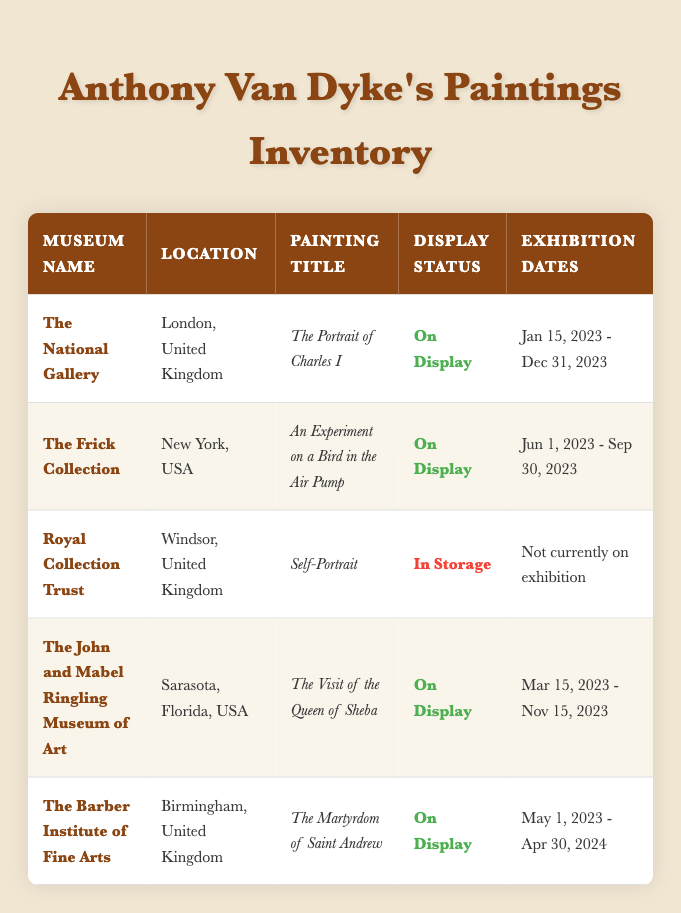What is the location of The Frick Collection? The table specifies the location of The Frick Collection under the "Location" column. It states that the museum is located in New York, USA.
Answer: New York, USA Which painting by Van Dyke is currently In Storage? By scanning the "Current Display Status" column, it is evident that the painting with the status "In Storage" is "Self-Portrait" held by the Royal Collection Trust.
Answer: Self-Portrait How many paintings are currently On Display? In the "Current Display Status" column, there are four paintings listed as "On Display." I counted each row where this status is present: The Portrait of Charles I, An Experiment on a Bird in the Air Pump, The Visit of the Queen of Sheba, and The Martyrdom of Saint Andrew.
Answer: 4 Is "The Martyrdom of Saint Andrew" currently on display? The table shows that the current display status of "The Martyrdom of Saint Andrew" is noted as "On Display." Therefore, it is true that it is currently being exhibited.
Answer: Yes Which museum has the longest ongoing exhibition for Van Dyke's paintings? I need to compare the exhibition dates of all paintings currently on display. The Barber Institute of Fine Arts has the exhibition lasting from May 1, 2023, to April 30, 2024, which is 12 months. The other exhibitions are shorter: The National Gallery till December 31, 2023, The Ringling Museum until November 15, 2023, and The Frick Collection until September 30, 2023. Therefore, The Barber Institute of Fine Arts has the longest exhibition duration.
Answer: The Barber Institute of Fine Arts What is the exhibition end date for "An Experiment on a Bird in the Air Pump"? Referring to the "Exhibition Dates" column under The Frick Collection, it indicates the painting "An Experiment on a Bird in the Air Pump" has an exhibition end date of September 30, 2023.
Answer: September 30, 2023 